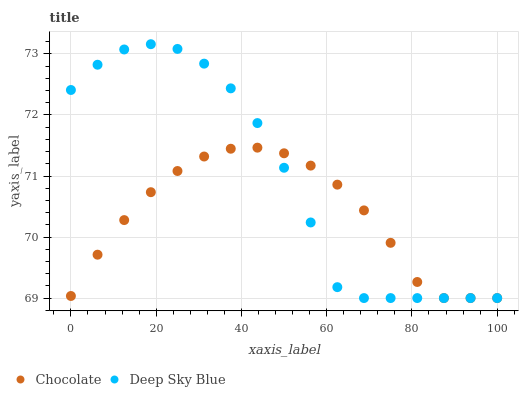Does Chocolate have the minimum area under the curve?
Answer yes or no. Yes. Does Deep Sky Blue have the maximum area under the curve?
Answer yes or no. Yes. Does Chocolate have the maximum area under the curve?
Answer yes or no. No. Is Chocolate the smoothest?
Answer yes or no. Yes. Is Deep Sky Blue the roughest?
Answer yes or no. Yes. Is Chocolate the roughest?
Answer yes or no. No. Does Deep Sky Blue have the lowest value?
Answer yes or no. Yes. Does Deep Sky Blue have the highest value?
Answer yes or no. Yes. Does Chocolate have the highest value?
Answer yes or no. No. Does Deep Sky Blue intersect Chocolate?
Answer yes or no. Yes. Is Deep Sky Blue less than Chocolate?
Answer yes or no. No. Is Deep Sky Blue greater than Chocolate?
Answer yes or no. No. 